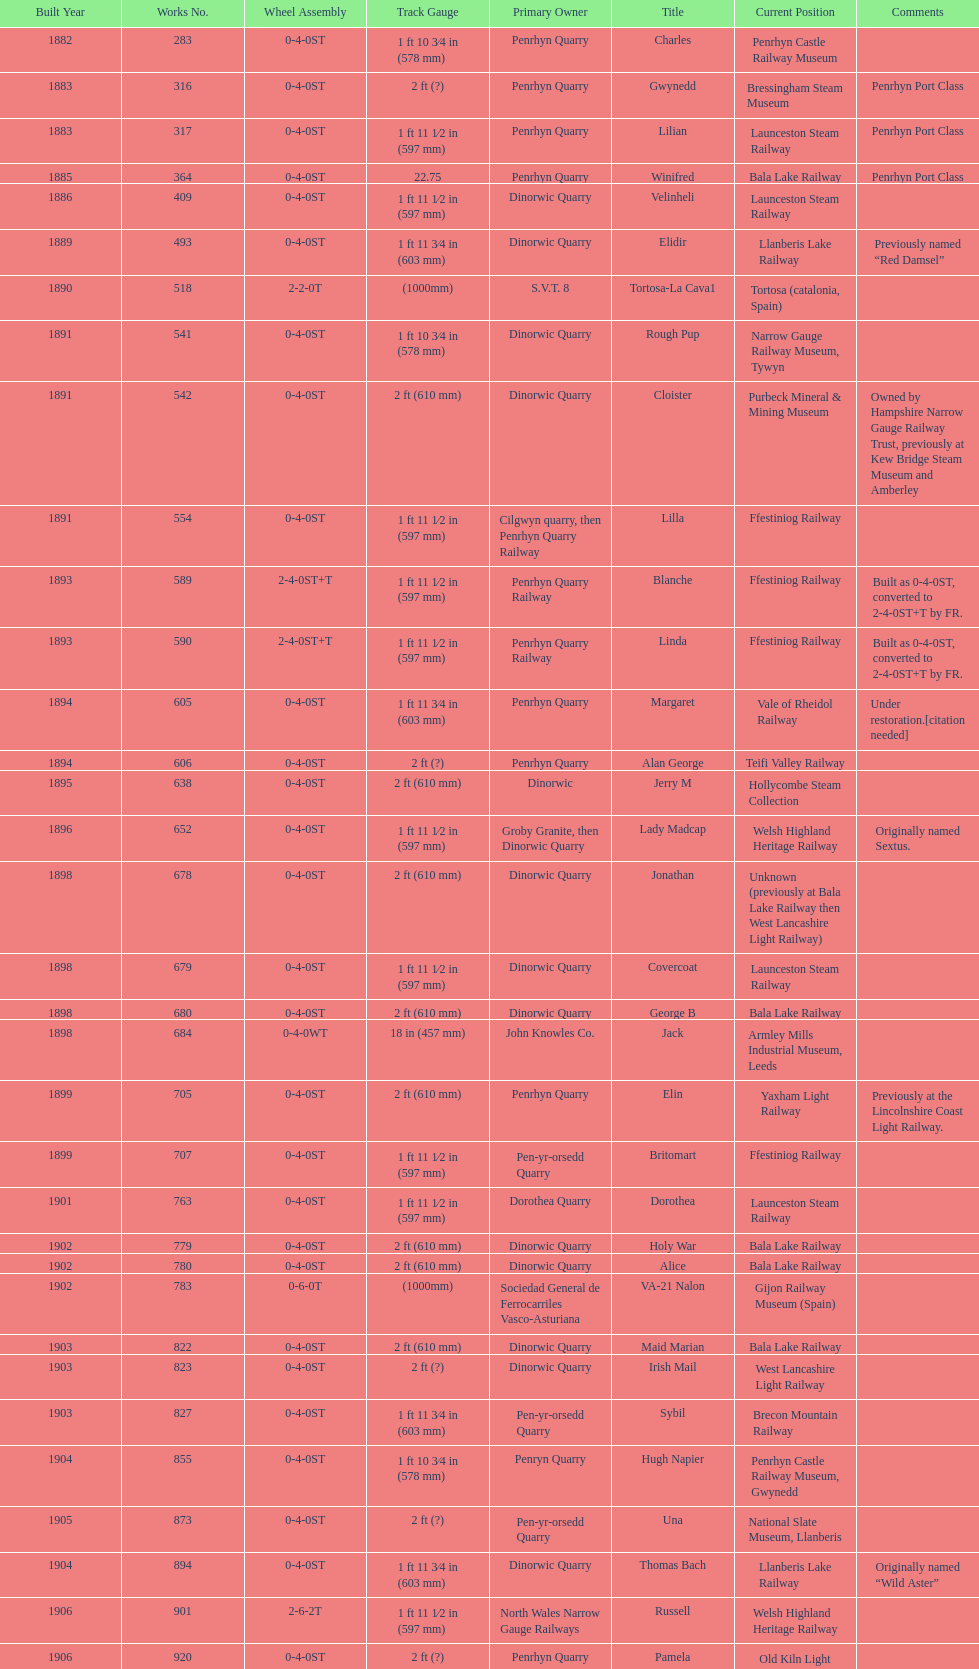Parse the table in full. {'header': ['Built Year', 'Works No.', 'Wheel Assembly', 'Track Gauge', 'Primary Owner', 'Title', 'Current Position', 'Comments'], 'rows': [['1882', '283', '0-4-0ST', '1\xa0ft 10\xa03⁄4\xa0in (578\xa0mm)', 'Penrhyn Quarry', 'Charles', 'Penrhyn Castle Railway Museum', ''], ['1883', '316', '0-4-0ST', '2\xa0ft (?)', 'Penrhyn Quarry', 'Gwynedd', 'Bressingham Steam Museum', 'Penrhyn Port Class'], ['1883', '317', '0-4-0ST', '1\xa0ft 11\xa01⁄2\xa0in (597\xa0mm)', 'Penrhyn Quarry', 'Lilian', 'Launceston Steam Railway', 'Penrhyn Port Class'], ['1885', '364', '0-4-0ST', '22.75', 'Penrhyn Quarry', 'Winifred', 'Bala Lake Railway', 'Penrhyn Port Class'], ['1886', '409', '0-4-0ST', '1\xa0ft 11\xa01⁄2\xa0in (597\xa0mm)', 'Dinorwic Quarry', 'Velinheli', 'Launceston Steam Railway', ''], ['1889', '493', '0-4-0ST', '1\xa0ft 11\xa03⁄4\xa0in (603\xa0mm)', 'Dinorwic Quarry', 'Elidir', 'Llanberis Lake Railway', 'Previously named “Red Damsel”'], ['1890', '518', '2-2-0T', '(1000mm)', 'S.V.T. 8', 'Tortosa-La Cava1', 'Tortosa (catalonia, Spain)', ''], ['1891', '541', '0-4-0ST', '1\xa0ft 10\xa03⁄4\xa0in (578\xa0mm)', 'Dinorwic Quarry', 'Rough Pup', 'Narrow Gauge Railway Museum, Tywyn', ''], ['1891', '542', '0-4-0ST', '2\xa0ft (610\xa0mm)', 'Dinorwic Quarry', 'Cloister', 'Purbeck Mineral & Mining Museum', 'Owned by Hampshire Narrow Gauge Railway Trust, previously at Kew Bridge Steam Museum and Amberley'], ['1891', '554', '0-4-0ST', '1\xa0ft 11\xa01⁄2\xa0in (597\xa0mm)', 'Cilgwyn quarry, then Penrhyn Quarry Railway', 'Lilla', 'Ffestiniog Railway', ''], ['1893', '589', '2-4-0ST+T', '1\xa0ft 11\xa01⁄2\xa0in (597\xa0mm)', 'Penrhyn Quarry Railway', 'Blanche', 'Ffestiniog Railway', 'Built as 0-4-0ST, converted to 2-4-0ST+T by FR.'], ['1893', '590', '2-4-0ST+T', '1\xa0ft 11\xa01⁄2\xa0in (597\xa0mm)', 'Penrhyn Quarry Railway', 'Linda', 'Ffestiniog Railway', 'Built as 0-4-0ST, converted to 2-4-0ST+T by FR.'], ['1894', '605', '0-4-0ST', '1\xa0ft 11\xa03⁄4\xa0in (603\xa0mm)', 'Penrhyn Quarry', 'Margaret', 'Vale of Rheidol Railway', 'Under restoration.[citation needed]'], ['1894', '606', '0-4-0ST', '2\xa0ft (?)', 'Penrhyn Quarry', 'Alan George', 'Teifi Valley Railway', ''], ['1895', '638', '0-4-0ST', '2\xa0ft (610\xa0mm)', 'Dinorwic', 'Jerry M', 'Hollycombe Steam Collection', ''], ['1896', '652', '0-4-0ST', '1\xa0ft 11\xa01⁄2\xa0in (597\xa0mm)', 'Groby Granite, then Dinorwic Quarry', 'Lady Madcap', 'Welsh Highland Heritage Railway', 'Originally named Sextus.'], ['1898', '678', '0-4-0ST', '2\xa0ft (610\xa0mm)', 'Dinorwic Quarry', 'Jonathan', 'Unknown (previously at Bala Lake Railway then West Lancashire Light Railway)', ''], ['1898', '679', '0-4-0ST', '1\xa0ft 11\xa01⁄2\xa0in (597\xa0mm)', 'Dinorwic Quarry', 'Covercoat', 'Launceston Steam Railway', ''], ['1898', '680', '0-4-0ST', '2\xa0ft (610\xa0mm)', 'Dinorwic Quarry', 'George B', 'Bala Lake Railway', ''], ['1898', '684', '0-4-0WT', '18\xa0in (457\xa0mm)', 'John Knowles Co.', 'Jack', 'Armley Mills Industrial Museum, Leeds', ''], ['1899', '705', '0-4-0ST', '2\xa0ft (610\xa0mm)', 'Penrhyn Quarry', 'Elin', 'Yaxham Light Railway', 'Previously at the Lincolnshire Coast Light Railway.'], ['1899', '707', '0-4-0ST', '1\xa0ft 11\xa01⁄2\xa0in (597\xa0mm)', 'Pen-yr-orsedd Quarry', 'Britomart', 'Ffestiniog Railway', ''], ['1901', '763', '0-4-0ST', '1\xa0ft 11\xa01⁄2\xa0in (597\xa0mm)', 'Dorothea Quarry', 'Dorothea', 'Launceston Steam Railway', ''], ['1902', '779', '0-4-0ST', '2\xa0ft (610\xa0mm)', 'Dinorwic Quarry', 'Holy War', 'Bala Lake Railway', ''], ['1902', '780', '0-4-0ST', '2\xa0ft (610\xa0mm)', 'Dinorwic Quarry', 'Alice', 'Bala Lake Railway', ''], ['1902', '783', '0-6-0T', '(1000mm)', 'Sociedad General de Ferrocarriles Vasco-Asturiana', 'VA-21 Nalon', 'Gijon Railway Museum (Spain)', ''], ['1903', '822', '0-4-0ST', '2\xa0ft (610\xa0mm)', 'Dinorwic Quarry', 'Maid Marian', 'Bala Lake Railway', ''], ['1903', '823', '0-4-0ST', '2\xa0ft (?)', 'Dinorwic Quarry', 'Irish Mail', 'West Lancashire Light Railway', ''], ['1903', '827', '0-4-0ST', '1\xa0ft 11\xa03⁄4\xa0in (603\xa0mm)', 'Pen-yr-orsedd Quarry', 'Sybil', 'Brecon Mountain Railway', ''], ['1904', '855', '0-4-0ST', '1\xa0ft 10\xa03⁄4\xa0in (578\xa0mm)', 'Penryn Quarry', 'Hugh Napier', 'Penrhyn Castle Railway Museum, Gwynedd', ''], ['1905', '873', '0-4-0ST', '2\xa0ft (?)', 'Pen-yr-orsedd Quarry', 'Una', 'National Slate Museum, Llanberis', ''], ['1904', '894', '0-4-0ST', '1\xa0ft 11\xa03⁄4\xa0in (603\xa0mm)', 'Dinorwic Quarry', 'Thomas Bach', 'Llanberis Lake Railway', 'Originally named “Wild Aster”'], ['1906', '901', '2-6-2T', '1\xa0ft 11\xa01⁄2\xa0in (597\xa0mm)', 'North Wales Narrow Gauge Railways', 'Russell', 'Welsh Highland Heritage Railway', ''], ['1906', '920', '0-4-0ST', '2\xa0ft (?)', 'Penrhyn Quarry', 'Pamela', 'Old Kiln Light Railway', ''], ['1909', '994', '0-4-0ST', '2\xa0ft (?)', 'Penrhyn Quarry', 'Bill Harvey', 'Bressingham Steam Museum', 'previously George Sholto'], ['1918', '1312', '4-6-0T', '1\xa0ft\xa011\xa01⁄2\xa0in (597\xa0mm)', 'British War Department\\nEFOP #203', '---', 'Pampas Safari, Gravataí, RS, Brazil', '[citation needed]'], ['1918\\nor\\n1921?', '1313', '0-6-2T', '3\xa0ft\xa03\xa03⁄8\xa0in (1,000\xa0mm)', 'British War Department\\nUsina Leão Utinga #1\\nUsina Laginha #1', '---', 'Usina Laginha, União dos Palmares, AL, Brazil', '[citation needed]'], ['1920', '1404', '0-4-0WT', '18\xa0in (457\xa0mm)', 'John Knowles Co.', 'Gwen', 'Richard Farmer current owner, Northridge, California, USA', ''], ['1922', '1429', '0-4-0ST', '2\xa0ft (610\xa0mm)', 'Dinorwic', 'Lady Joan', 'Bredgar and Wormshill Light Railway', ''], ['1922', '1430', '0-4-0ST', '1\xa0ft 11\xa03⁄4\xa0in (603\xa0mm)', 'Dinorwic Quarry', 'Dolbadarn', 'Llanberis Lake Railway', ''], ['1937', '1859', '0-4-2T', '2\xa0ft (?)', 'Umtwalumi Valley Estate, Natal', '16 Carlisle', 'South Tynedale Railway', ''], ['1940', '2075', '0-4-2T', '2\xa0ft (?)', 'Chaka’s Kraal Sugar Estates, Natal', 'Chaka’s Kraal No. 6', 'North Gloucestershire Railway', ''], ['1954', '3815', '2-6-2T', '2\xa0ft 6\xa0in (762\xa0mm)', 'Sierra Leone Government Railway', '14', 'Welshpool and Llanfair Light Railway', ''], ['1971', '3902', '0-4-2ST', '2\xa0ft (610\xa0mm)', 'Trangkil Sugar Mill, Indonesia', 'Trangkil No.4', 'Statfold Barn Railway', 'Converted from 750\xa0mm (2\xa0ft\xa05\xa01⁄2\xa0in) gauge. Last steam locomotive to be built by Hunslet, and the last industrial steam locomotive built in Britain.']]} What is the name of the last locomotive to be located at the bressingham steam museum? Gwynedd. 